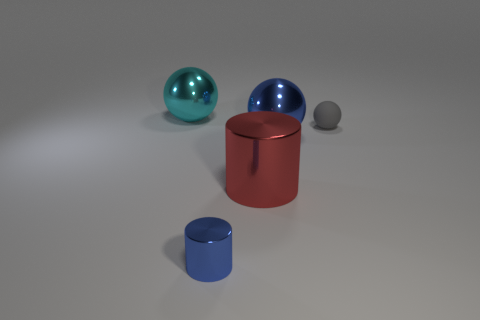Is there any other thing that is the same material as the small gray thing?
Make the answer very short. No. How many other objects are the same material as the blue sphere?
Offer a very short reply. 3. What number of metal things are there?
Your answer should be very brief. 4. What is the material of the gray thing that is the same shape as the cyan thing?
Your response must be concise. Rubber. Does the blue object to the right of the blue metallic cylinder have the same material as the big cylinder?
Provide a succinct answer. Yes. Is the number of tiny gray matte objects that are in front of the gray thing greater than the number of big cyan shiny spheres that are on the right side of the tiny metallic thing?
Make the answer very short. No. What is the size of the gray object?
Make the answer very short. Small. There is a cyan object that is the same material as the blue ball; what is its shape?
Make the answer very short. Sphere. There is a large red object that is on the left side of the small matte sphere; is its shape the same as the tiny blue object?
Your answer should be compact. Yes. What number of things are brown rubber blocks or gray balls?
Your response must be concise. 1. 